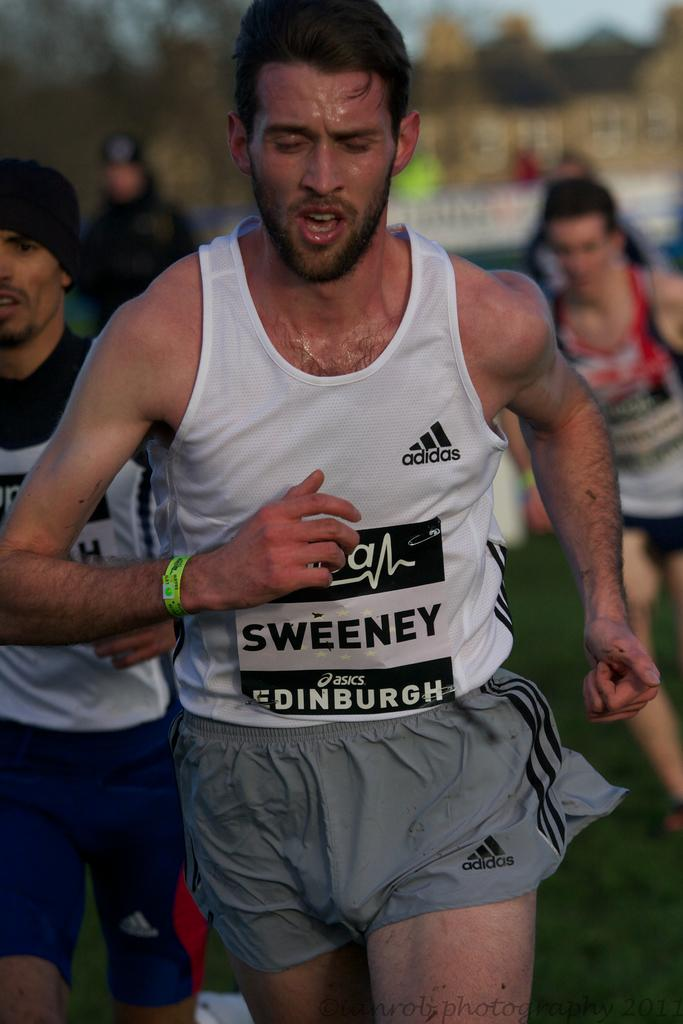Provide a one-sentence caption for the provided image. Men are running in a race sweating in adidas outfits. 